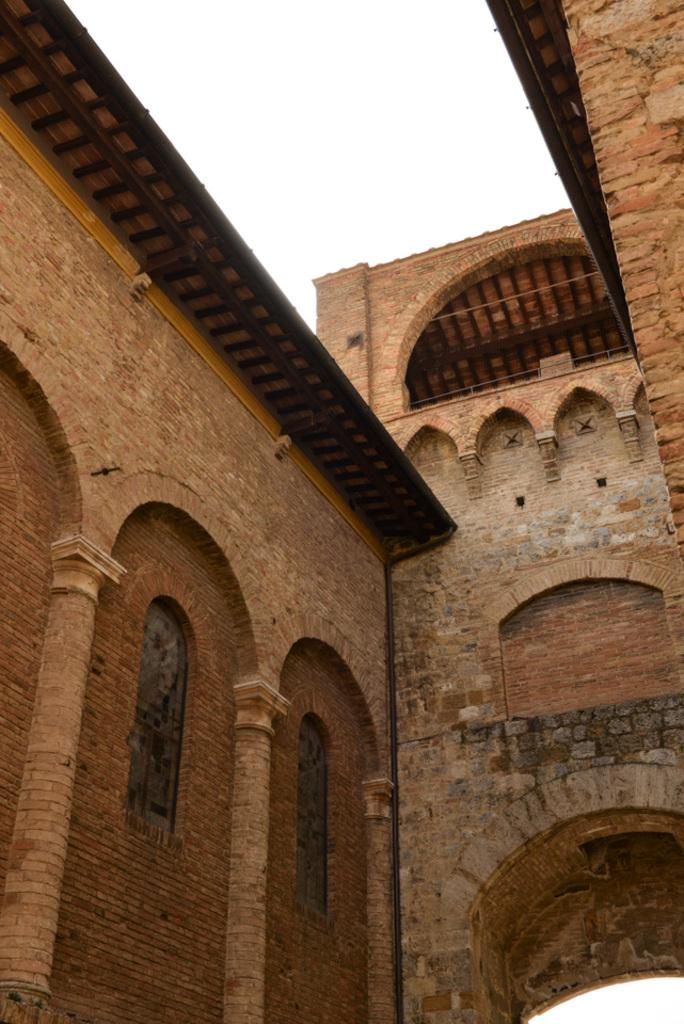What is the main structure visible in the image? There is a building in the image. What material is the building made of? The building is made up of red bricks. How does the building slip down the hill in the image? The building does not slip down a hill in the image; it is standing upright and made of red bricks. 